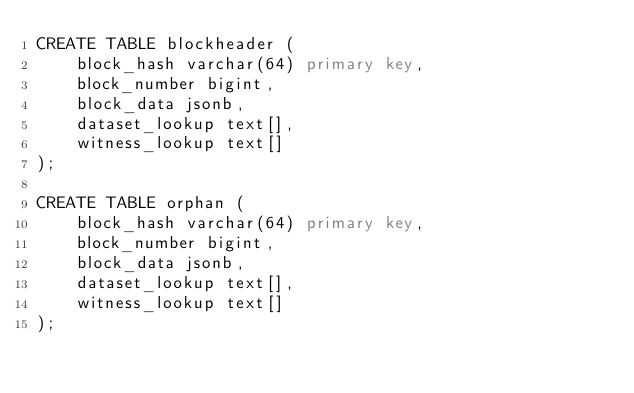<code> <loc_0><loc_0><loc_500><loc_500><_SQL_>CREATE TABLE blockheader (
    block_hash varchar(64) primary key,
    block_number bigint,
    block_data jsonb,
    dataset_lookup text[],
    witness_lookup text[]
);

CREATE TABLE orphan (
    block_hash varchar(64) primary key,
    block_number bigint,
    block_data jsonb,
    dataset_lookup text[],
    witness_lookup text[]
);
</code> 